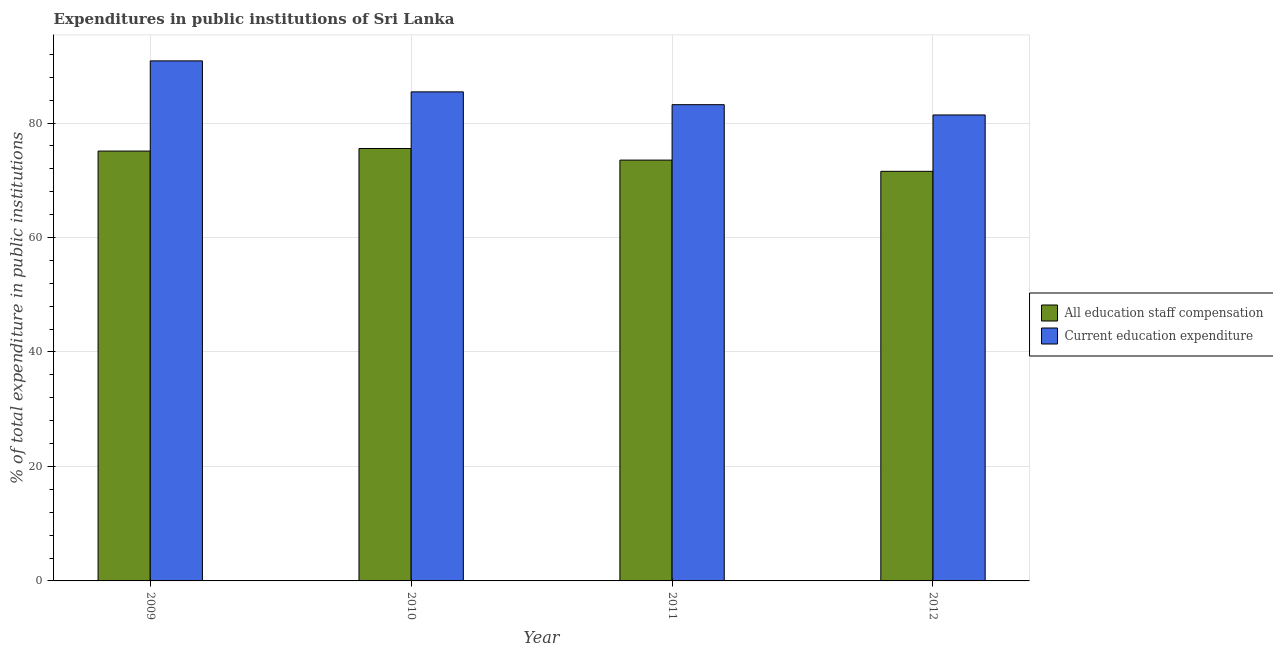How many different coloured bars are there?
Ensure brevity in your answer.  2. Are the number of bars per tick equal to the number of legend labels?
Your answer should be compact. Yes. How many bars are there on the 1st tick from the right?
Offer a terse response. 2. In how many cases, is the number of bars for a given year not equal to the number of legend labels?
Your answer should be very brief. 0. What is the expenditure in staff compensation in 2010?
Provide a succinct answer. 75.55. Across all years, what is the maximum expenditure in staff compensation?
Give a very brief answer. 75.55. Across all years, what is the minimum expenditure in education?
Your response must be concise. 81.41. In which year was the expenditure in education maximum?
Make the answer very short. 2009. In which year was the expenditure in education minimum?
Give a very brief answer. 2012. What is the total expenditure in education in the graph?
Give a very brief answer. 340.91. What is the difference between the expenditure in staff compensation in 2009 and that in 2011?
Give a very brief answer. 1.58. What is the difference between the expenditure in education in 2012 and the expenditure in staff compensation in 2010?
Offer a terse response. -4.03. What is the average expenditure in staff compensation per year?
Provide a succinct answer. 73.93. In the year 2009, what is the difference between the expenditure in staff compensation and expenditure in education?
Provide a succinct answer. 0. What is the ratio of the expenditure in staff compensation in 2009 to that in 2011?
Make the answer very short. 1.02. Is the expenditure in education in 2009 less than that in 2011?
Make the answer very short. No. Is the difference between the expenditure in education in 2009 and 2011 greater than the difference between the expenditure in staff compensation in 2009 and 2011?
Your response must be concise. No. What is the difference between the highest and the second highest expenditure in staff compensation?
Make the answer very short. 0.45. What is the difference between the highest and the lowest expenditure in staff compensation?
Offer a very short reply. 3.99. In how many years, is the expenditure in education greater than the average expenditure in education taken over all years?
Make the answer very short. 2. Is the sum of the expenditure in staff compensation in 2011 and 2012 greater than the maximum expenditure in education across all years?
Offer a terse response. Yes. What does the 1st bar from the left in 2012 represents?
Provide a short and direct response. All education staff compensation. What does the 1st bar from the right in 2009 represents?
Offer a terse response. Current education expenditure. How many bars are there?
Ensure brevity in your answer.  8. Are all the bars in the graph horizontal?
Your response must be concise. No. What is the difference between two consecutive major ticks on the Y-axis?
Keep it short and to the point. 20. Does the graph contain any zero values?
Provide a succinct answer. No. Does the graph contain grids?
Offer a very short reply. Yes. Where does the legend appear in the graph?
Give a very brief answer. Center right. What is the title of the graph?
Ensure brevity in your answer.  Expenditures in public institutions of Sri Lanka. Does "Female" appear as one of the legend labels in the graph?
Your answer should be compact. No. What is the label or title of the X-axis?
Keep it short and to the point. Year. What is the label or title of the Y-axis?
Your response must be concise. % of total expenditure in public institutions. What is the % of total expenditure in public institutions in All education staff compensation in 2009?
Your answer should be very brief. 75.1. What is the % of total expenditure in public institutions in Current education expenditure in 2009?
Make the answer very short. 90.86. What is the % of total expenditure in public institutions of All education staff compensation in 2010?
Ensure brevity in your answer.  75.55. What is the % of total expenditure in public institutions in Current education expenditure in 2010?
Your answer should be very brief. 85.44. What is the % of total expenditure in public institutions in All education staff compensation in 2011?
Your answer should be compact. 73.52. What is the % of total expenditure in public institutions in Current education expenditure in 2011?
Give a very brief answer. 83.2. What is the % of total expenditure in public institutions of All education staff compensation in 2012?
Make the answer very short. 71.56. What is the % of total expenditure in public institutions of Current education expenditure in 2012?
Provide a short and direct response. 81.41. Across all years, what is the maximum % of total expenditure in public institutions of All education staff compensation?
Offer a terse response. 75.55. Across all years, what is the maximum % of total expenditure in public institutions in Current education expenditure?
Give a very brief answer. 90.86. Across all years, what is the minimum % of total expenditure in public institutions in All education staff compensation?
Give a very brief answer. 71.56. Across all years, what is the minimum % of total expenditure in public institutions in Current education expenditure?
Make the answer very short. 81.41. What is the total % of total expenditure in public institutions of All education staff compensation in the graph?
Offer a terse response. 295.73. What is the total % of total expenditure in public institutions of Current education expenditure in the graph?
Offer a terse response. 340.91. What is the difference between the % of total expenditure in public institutions in All education staff compensation in 2009 and that in 2010?
Provide a succinct answer. -0.45. What is the difference between the % of total expenditure in public institutions in Current education expenditure in 2009 and that in 2010?
Provide a succinct answer. 5.42. What is the difference between the % of total expenditure in public institutions in All education staff compensation in 2009 and that in 2011?
Provide a succinct answer. 1.58. What is the difference between the % of total expenditure in public institutions of Current education expenditure in 2009 and that in 2011?
Offer a terse response. 7.65. What is the difference between the % of total expenditure in public institutions in All education staff compensation in 2009 and that in 2012?
Keep it short and to the point. 3.54. What is the difference between the % of total expenditure in public institutions in Current education expenditure in 2009 and that in 2012?
Offer a very short reply. 9.45. What is the difference between the % of total expenditure in public institutions in All education staff compensation in 2010 and that in 2011?
Give a very brief answer. 2.03. What is the difference between the % of total expenditure in public institutions of Current education expenditure in 2010 and that in 2011?
Provide a succinct answer. 2.24. What is the difference between the % of total expenditure in public institutions of All education staff compensation in 2010 and that in 2012?
Your response must be concise. 3.99. What is the difference between the % of total expenditure in public institutions of Current education expenditure in 2010 and that in 2012?
Your answer should be compact. 4.03. What is the difference between the % of total expenditure in public institutions in All education staff compensation in 2011 and that in 2012?
Keep it short and to the point. 1.96. What is the difference between the % of total expenditure in public institutions of Current education expenditure in 2011 and that in 2012?
Make the answer very short. 1.79. What is the difference between the % of total expenditure in public institutions in All education staff compensation in 2009 and the % of total expenditure in public institutions in Current education expenditure in 2010?
Give a very brief answer. -10.34. What is the difference between the % of total expenditure in public institutions in All education staff compensation in 2009 and the % of total expenditure in public institutions in Current education expenditure in 2011?
Your response must be concise. -8.1. What is the difference between the % of total expenditure in public institutions of All education staff compensation in 2009 and the % of total expenditure in public institutions of Current education expenditure in 2012?
Provide a succinct answer. -6.31. What is the difference between the % of total expenditure in public institutions in All education staff compensation in 2010 and the % of total expenditure in public institutions in Current education expenditure in 2011?
Your response must be concise. -7.66. What is the difference between the % of total expenditure in public institutions in All education staff compensation in 2010 and the % of total expenditure in public institutions in Current education expenditure in 2012?
Your answer should be very brief. -5.86. What is the difference between the % of total expenditure in public institutions in All education staff compensation in 2011 and the % of total expenditure in public institutions in Current education expenditure in 2012?
Offer a terse response. -7.89. What is the average % of total expenditure in public institutions in All education staff compensation per year?
Offer a very short reply. 73.93. What is the average % of total expenditure in public institutions of Current education expenditure per year?
Provide a succinct answer. 85.23. In the year 2009, what is the difference between the % of total expenditure in public institutions in All education staff compensation and % of total expenditure in public institutions in Current education expenditure?
Keep it short and to the point. -15.76. In the year 2010, what is the difference between the % of total expenditure in public institutions of All education staff compensation and % of total expenditure in public institutions of Current education expenditure?
Provide a short and direct response. -9.89. In the year 2011, what is the difference between the % of total expenditure in public institutions in All education staff compensation and % of total expenditure in public institutions in Current education expenditure?
Ensure brevity in your answer.  -9.68. In the year 2012, what is the difference between the % of total expenditure in public institutions in All education staff compensation and % of total expenditure in public institutions in Current education expenditure?
Make the answer very short. -9.85. What is the ratio of the % of total expenditure in public institutions of Current education expenditure in 2009 to that in 2010?
Offer a very short reply. 1.06. What is the ratio of the % of total expenditure in public institutions of All education staff compensation in 2009 to that in 2011?
Offer a terse response. 1.02. What is the ratio of the % of total expenditure in public institutions in Current education expenditure in 2009 to that in 2011?
Ensure brevity in your answer.  1.09. What is the ratio of the % of total expenditure in public institutions of All education staff compensation in 2009 to that in 2012?
Make the answer very short. 1.05. What is the ratio of the % of total expenditure in public institutions in Current education expenditure in 2009 to that in 2012?
Offer a terse response. 1.12. What is the ratio of the % of total expenditure in public institutions in All education staff compensation in 2010 to that in 2011?
Give a very brief answer. 1.03. What is the ratio of the % of total expenditure in public institutions in Current education expenditure in 2010 to that in 2011?
Provide a short and direct response. 1.03. What is the ratio of the % of total expenditure in public institutions of All education staff compensation in 2010 to that in 2012?
Your response must be concise. 1.06. What is the ratio of the % of total expenditure in public institutions of Current education expenditure in 2010 to that in 2012?
Your answer should be very brief. 1.05. What is the ratio of the % of total expenditure in public institutions in All education staff compensation in 2011 to that in 2012?
Your response must be concise. 1.03. What is the ratio of the % of total expenditure in public institutions of Current education expenditure in 2011 to that in 2012?
Your answer should be very brief. 1.02. What is the difference between the highest and the second highest % of total expenditure in public institutions in All education staff compensation?
Your response must be concise. 0.45. What is the difference between the highest and the second highest % of total expenditure in public institutions of Current education expenditure?
Your response must be concise. 5.42. What is the difference between the highest and the lowest % of total expenditure in public institutions of All education staff compensation?
Offer a very short reply. 3.99. What is the difference between the highest and the lowest % of total expenditure in public institutions in Current education expenditure?
Provide a succinct answer. 9.45. 